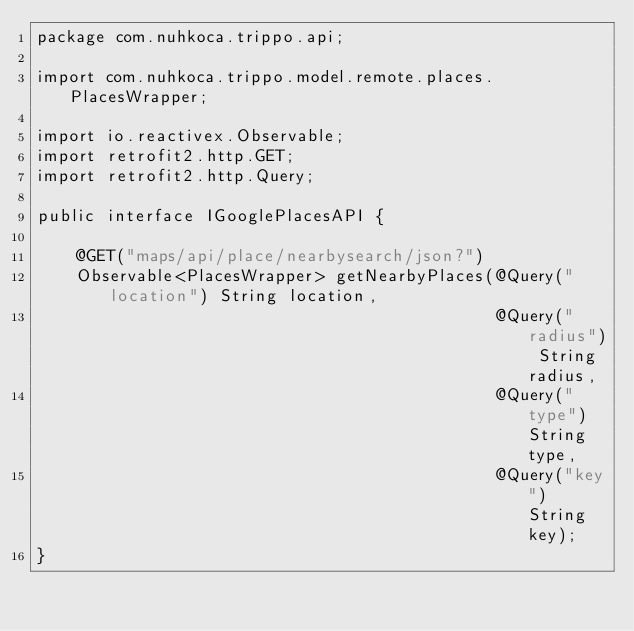<code> <loc_0><loc_0><loc_500><loc_500><_Java_>package com.nuhkoca.trippo.api;

import com.nuhkoca.trippo.model.remote.places.PlacesWrapper;

import io.reactivex.Observable;
import retrofit2.http.GET;
import retrofit2.http.Query;

public interface IGooglePlacesAPI {

    @GET("maps/api/place/nearbysearch/json?")
    Observable<PlacesWrapper> getNearbyPlaces(@Query("location") String location,
                                              @Query("radius") String radius,
                                              @Query("type") String type,
                                              @Query("key") String key);
}</code> 